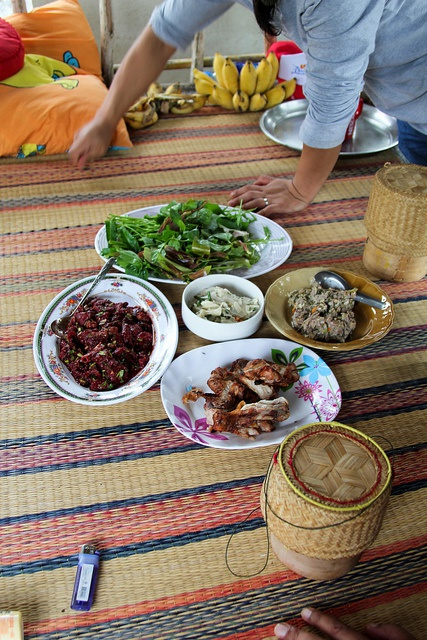Describe the objects in this image and their specific colors. I can see dining table in lightgray, tan, gray, and black tones, people in lightgray, gray, darkgray, and brown tones, bowl in lightgray, black, lavender, maroon, and gray tones, bowl in lightgray, olive, tan, black, and gray tones, and banana in lightgray, olive, and tan tones in this image. 